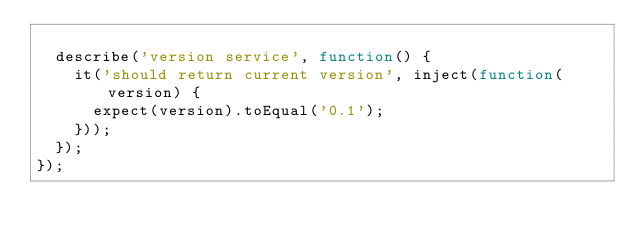<code> <loc_0><loc_0><loc_500><loc_500><_JavaScript_>
  describe('version service', function() {
    it('should return current version', inject(function(version) {
      expect(version).toEqual('0.1');
    }));
  });
});
</code> 